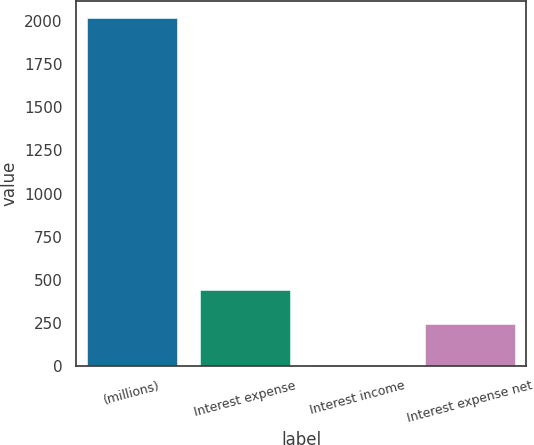Convert chart. <chart><loc_0><loc_0><loc_500><loc_500><bar_chart><fcel>(millions)<fcel>Interest expense<fcel>Interest income<fcel>Interest expense net<nl><fcel>2015<fcel>444.09<fcel>10.1<fcel>243.6<nl></chart> 